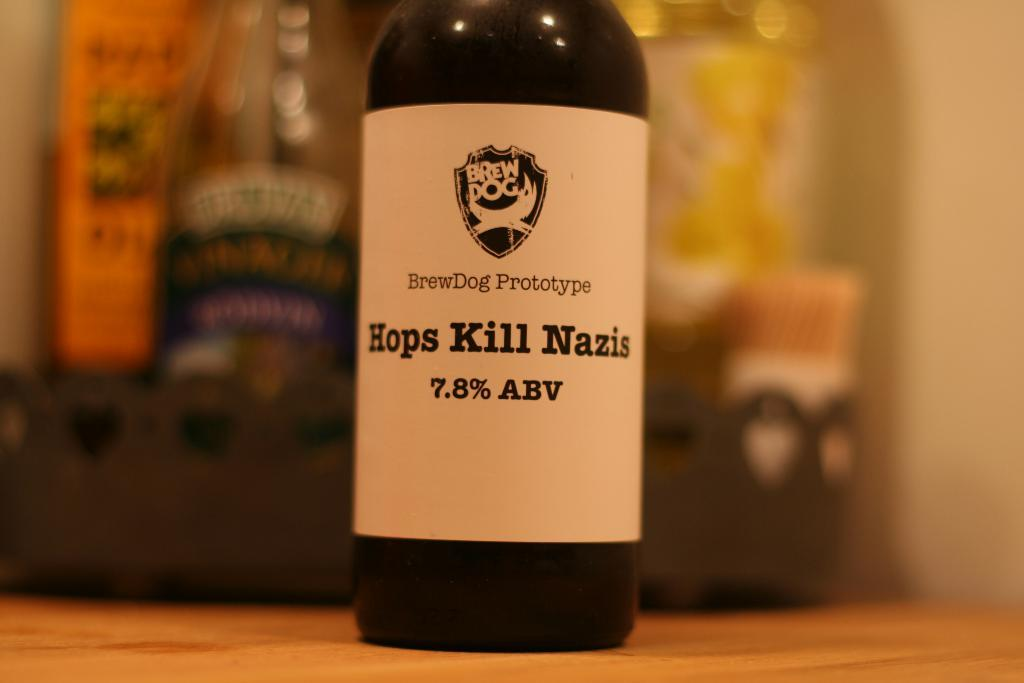<image>
Provide a brief description of the given image. A bottle from BrewDog that is called Hops Kill Nazis. 